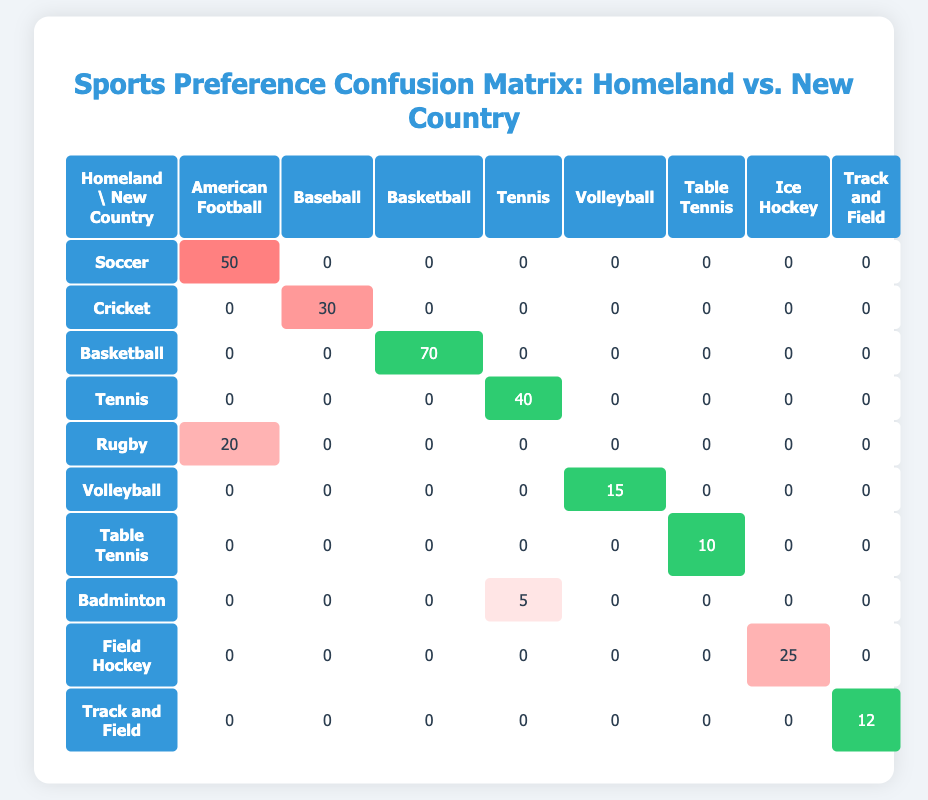What is the highest count for a sport preference from the homeland to the new country? The table shows the highest count in the "Basketball" to "Basketball" row with a value of 70.
Answer: 70 Which new country sport has the least preference among the immigrants from the homeland? Looking at the counts for each new country sport, "Table Tennis" has the lowest value of 10.
Answer: Table Tennis How many people prefer Soccer in the new country? The row for Soccer shows a count of 50, indicating that 50 people prefer Soccer in the new country.
Answer: 50 What is the total preference count for Tennis across both categories? The counts for Tennis are 40 from homeland and 5 from Badminton also counts toward Tennis. Therefore, the total preference count is 40 + 5 = 45.
Answer: 45 Is there any sport that has the same preference count for both homeland and new country? From the table, "Basketball" and "Tennis" show identical counts (70 and 40 respectively), which confirms that there are sports with matching counts.
Answer: Yes Which sport has the highest count from the homeland to American Football? The highest count to American Football is the combination of Soccer (50) and Rugby (20), totaling 70.
Answer: 70 How many people participated in Volleyball in both categories combined? The count for Volleyball is 15. There is no value showing additional preferences for Volleyball from the new country; hence, the total is 15.
Answer: 15 Are there more people who prefer Baseball from the new country than those who prefer Cricket from the homeland? Based on the data, the count for Baseball is 30 and for Cricket from the homeland it's 0. Hence, yes, 30 is greater than 0.
Answer: Yes Which sport has a preference count lower than 20 when comparing homeland to new country? Only the sport "Table Tennis," with a count of 10, and "Volleyball" with a count of 15 have numbers lower than 20.
Answer: Table Tennis, Volleyball 